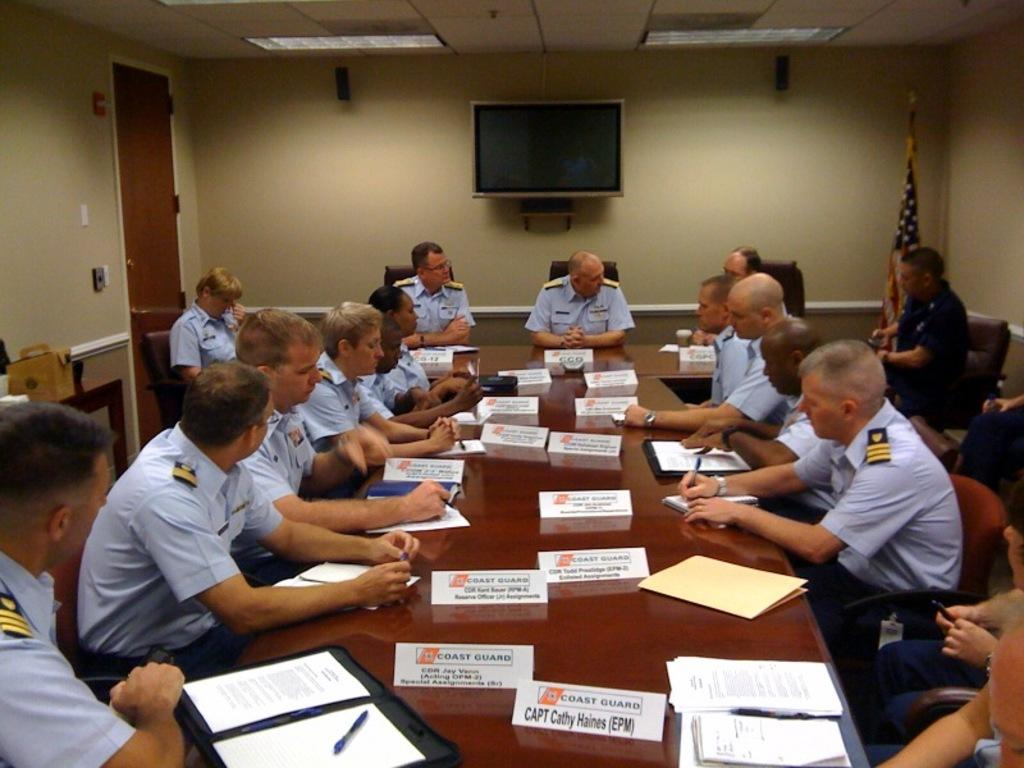<image>
Offer a succinct explanation of the picture presented. people at a Coast Guard meeting with name placards on a table like Capt Cathy Haines (EMP) 